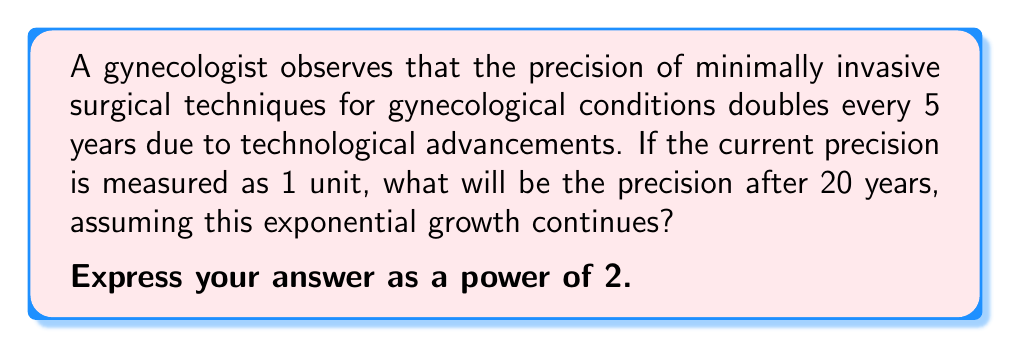Teach me how to tackle this problem. Let's approach this step-by-step:

1) We're dealing with exponential growth, where the precision doubles every 5 years.

2) The general form of exponential growth is:

   $$ A = A_0 \cdot b^t $$

   Where:
   $A$ is the final amount
   $A_0$ is the initial amount
   $b$ is the growth factor
   $t$ is the number of time periods

3) In this case:
   $A_0 = 1$ (initial precision)
   $b = 2$ (doubles every period)
   $t = 20 \div 5 = 4$ (number of 5-year periods in 20 years)

4) Plugging these values into our equation:

   $$ A = 1 \cdot 2^4 $$

5) This simplifies to:

   $$ A = 2^4 $$

Therefore, after 20 years, the precision will be $2^4$ times the current precision.
Answer: $2^4$ 